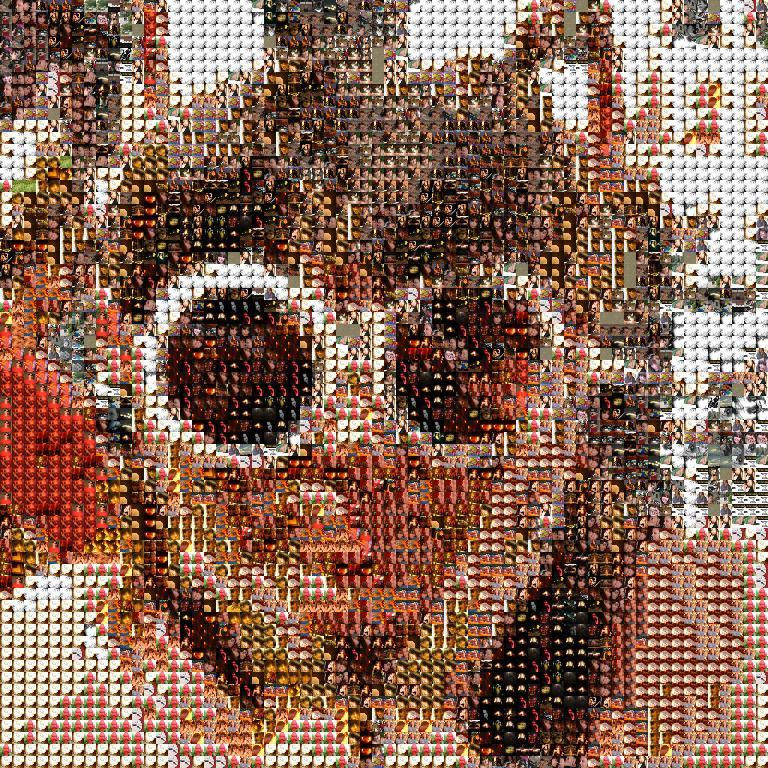What can be observed about the nature of the image? The image is edited. What is the main subject in the image? There is a person in the center of the image. What type of boats can be seen in the image? There are no boats present in the image. What team is the person in the image a part of? The image does not provide any information about the person being part of a team. 